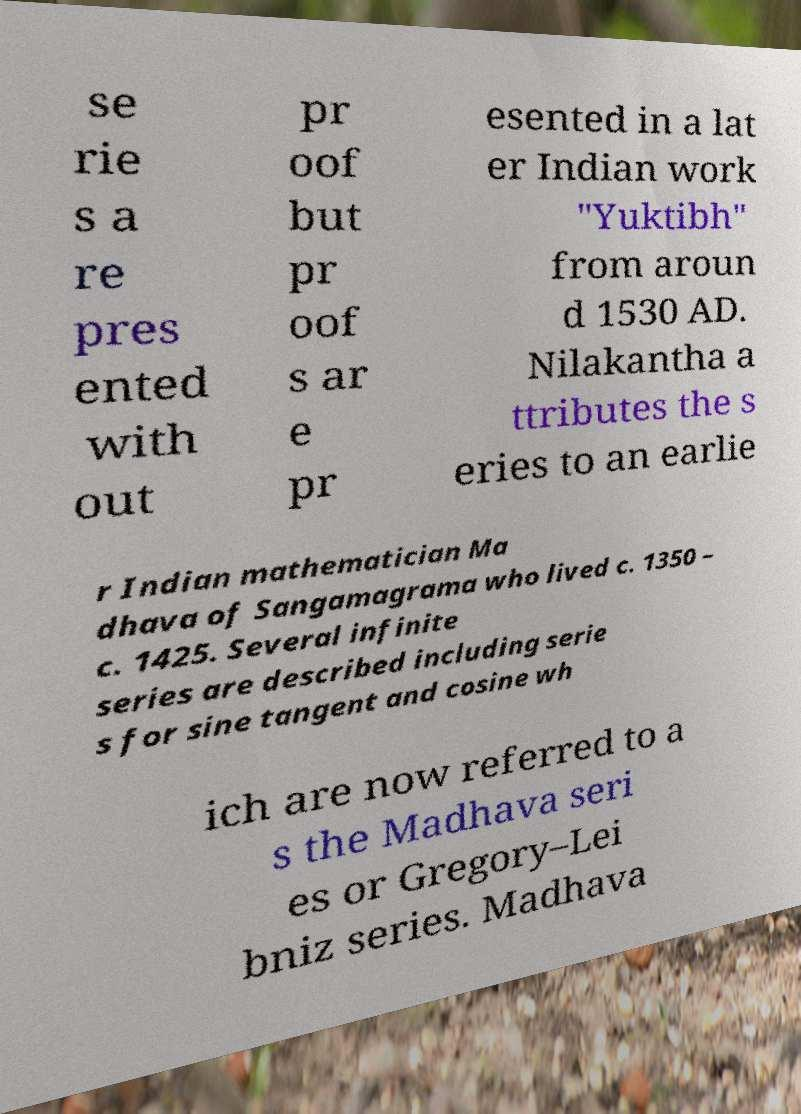I need the written content from this picture converted into text. Can you do that? se rie s a re pres ented with out pr oof but pr oof s ar e pr esented in a lat er Indian work "Yuktibh" from aroun d 1530 AD. Nilakantha a ttributes the s eries to an earlie r Indian mathematician Ma dhava of Sangamagrama who lived c. 1350 – c. 1425. Several infinite series are described including serie s for sine tangent and cosine wh ich are now referred to a s the Madhava seri es or Gregory–Lei bniz series. Madhava 